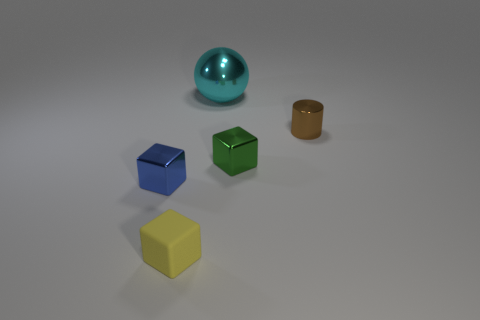There is a tiny blue thing that is the same shape as the green shiny object; what is its material?
Your response must be concise. Metal. What shape is the thing that is behind the tiny metal object on the right side of the tiny cube right of the tiny rubber object?
Give a very brief answer. Sphere. There is a shiny object that is both in front of the brown cylinder and right of the large shiny thing; what shape is it?
Keep it short and to the point. Cube. How many things are either small brown shiny cylinders or tiny objects to the left of the tiny brown metal cylinder?
Give a very brief answer. 4. Is the material of the cylinder the same as the yellow thing?
Your response must be concise. No. What number of other objects are the same shape as the green thing?
Make the answer very short. 2. There is a thing that is to the right of the yellow block and in front of the brown metal cylinder; what is its size?
Provide a succinct answer. Small. How many metallic things are large purple cylinders or small blue objects?
Make the answer very short. 1. Is the shape of the tiny shiny object that is to the right of the green shiny object the same as the thing that is behind the small brown object?
Ensure brevity in your answer.  No. Are there any tiny green blocks made of the same material as the tiny brown cylinder?
Give a very brief answer. Yes. 